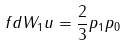Convert formula to latex. <formula><loc_0><loc_0><loc_500><loc_500>\ f d { W _ { 1 } } { u } = \frac { 2 } { 3 } p _ { 1 } p _ { 0 }</formula> 